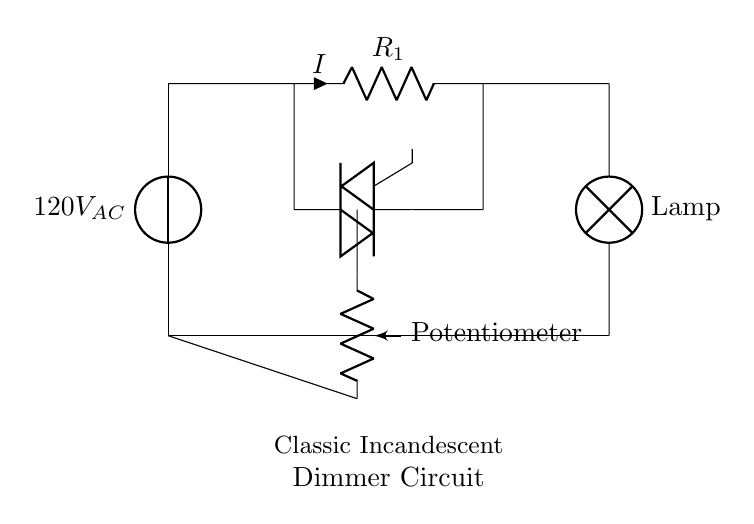What is the source voltage in the circuit? The source voltage is indicated as 120V AC, shown at the top of the circuit diagram.
Answer: 120V AC What component controls the current flow to the lamp? The component that controls the current flow is the triac, which is positioned between the resistor and the lamp in the circuit diagram.
Answer: Triac What is the function of the potentiometer in this circuit? The potentiometer acts as a variable resistor, allowing the user to adjust the brightness of the lamp by varying the resistance in the circuit.
Answer: Adjust brightness What is the direction of current flow in this circuit? The current flows from the voltage source, through the resistor, to the triac, and finally to the lamp before returning to the source, which is established by the direction arrows.
Answer: Clockwise How does the triac affect the lamp's brightness? The triac can be triggered on and off during the AC cycle, effectively controlling how much power reaches the lamp, which in turn adjusts its brightness.
Answer: Controls power What is the purpose of the resistor in this circuit? The resistor limits the current that flows through the circuit, ensuring the components operate within safe levels.
Answer: Current limiting Which component is used to adjust the lamp's intensity? The potentiometer is used to adjust the intensity of the lamp by varying its resistance, which influences the current flowing to the lamp.
Answer: Potentiometer 